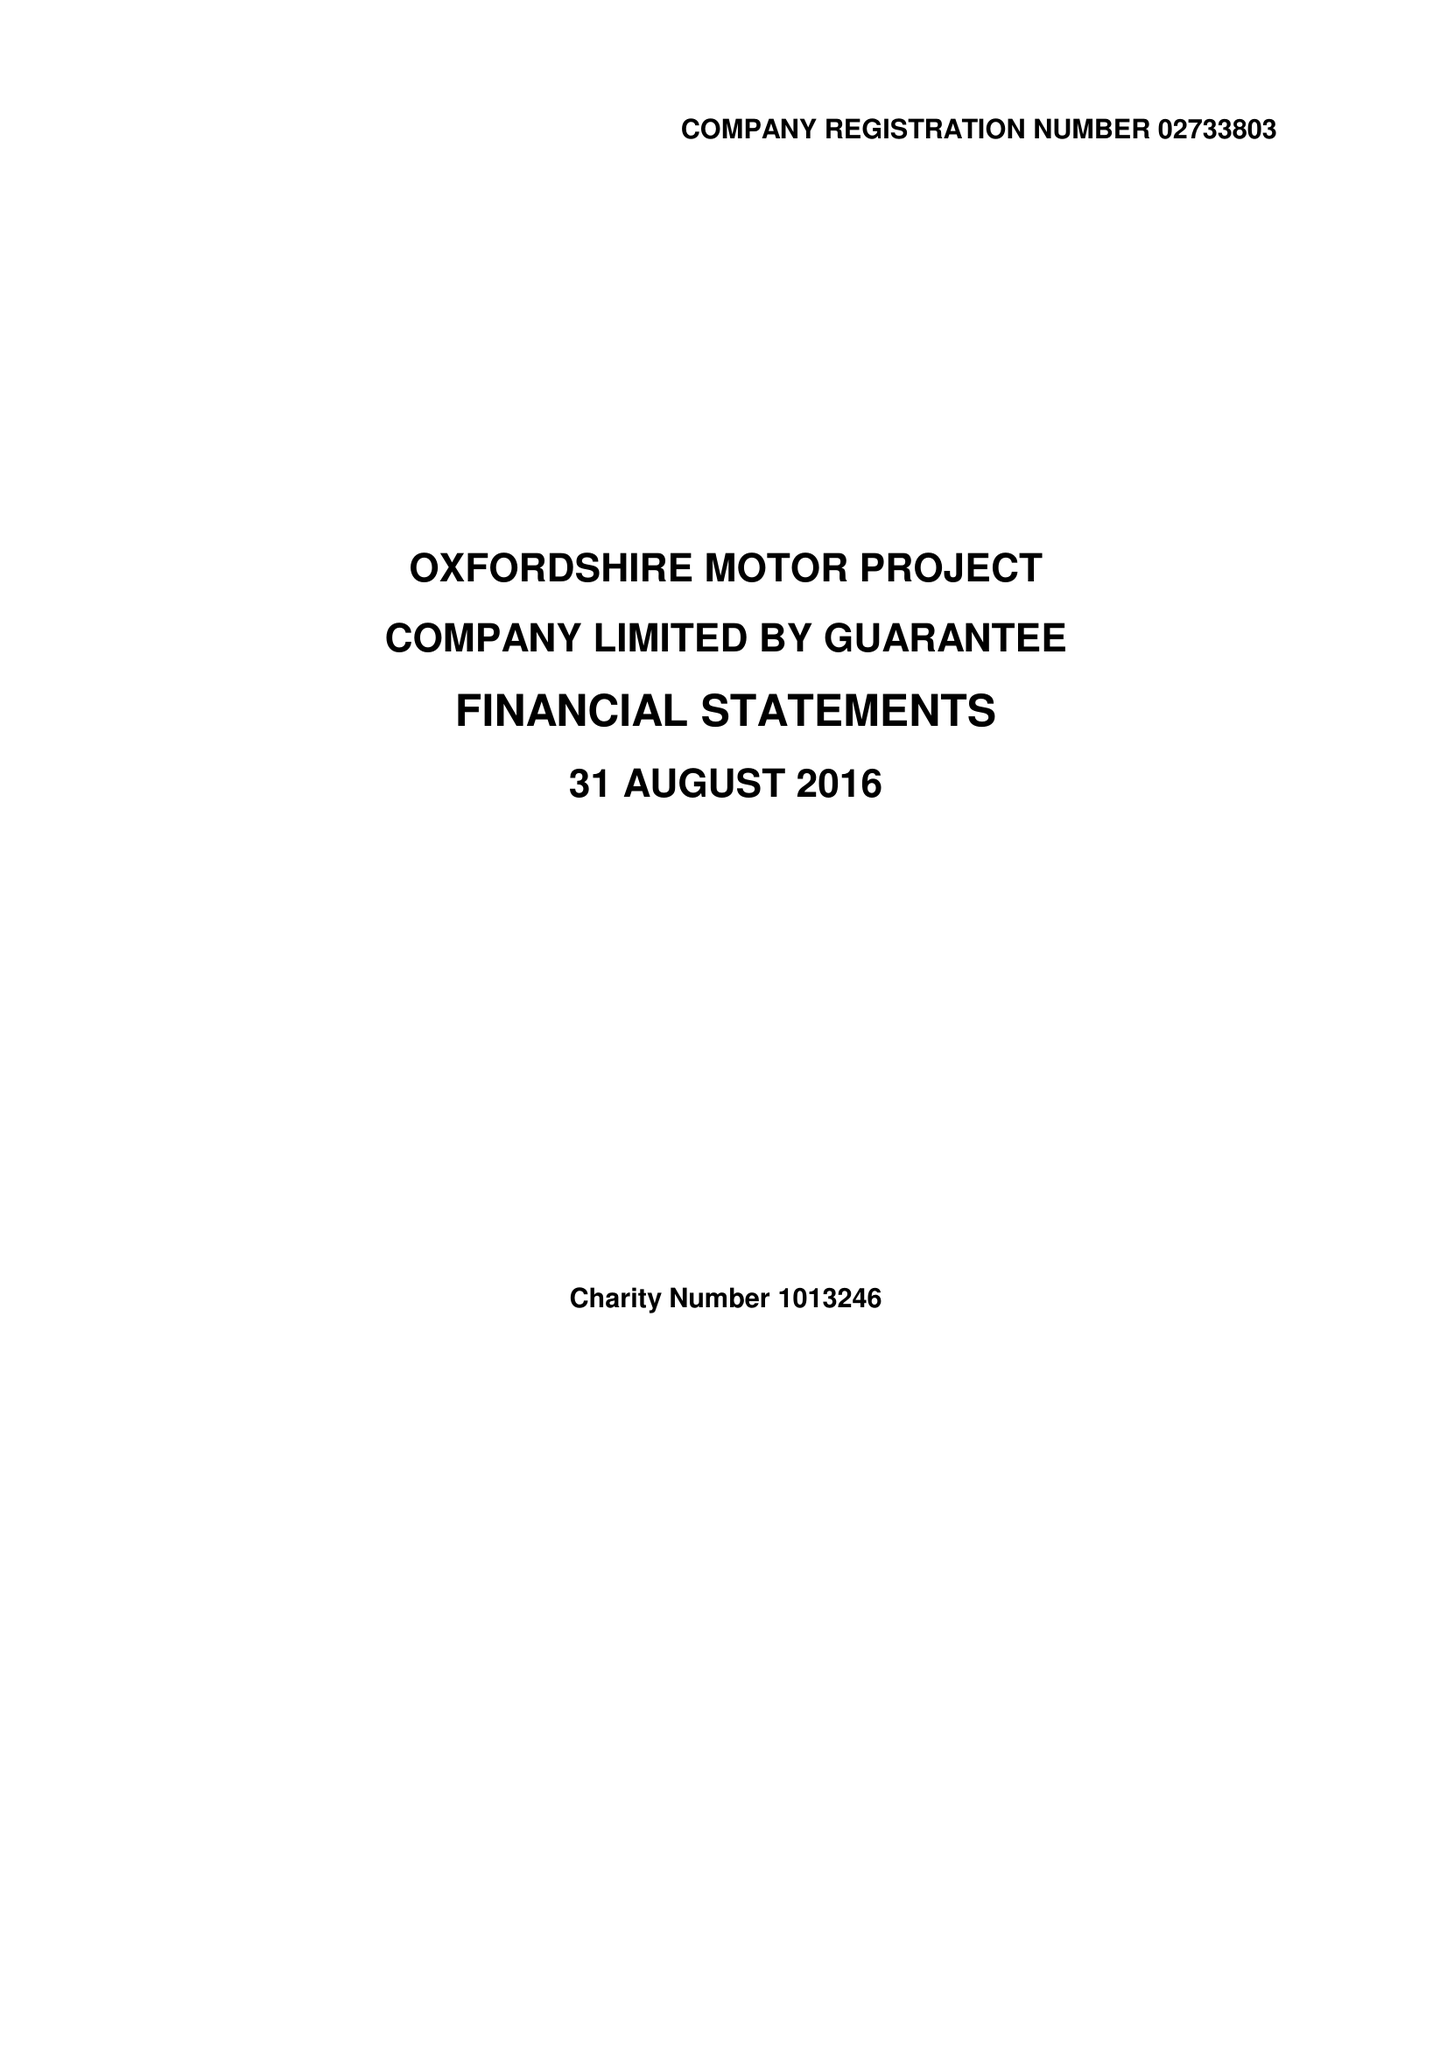What is the value for the charity_number?
Answer the question using a single word or phrase. 1013246 